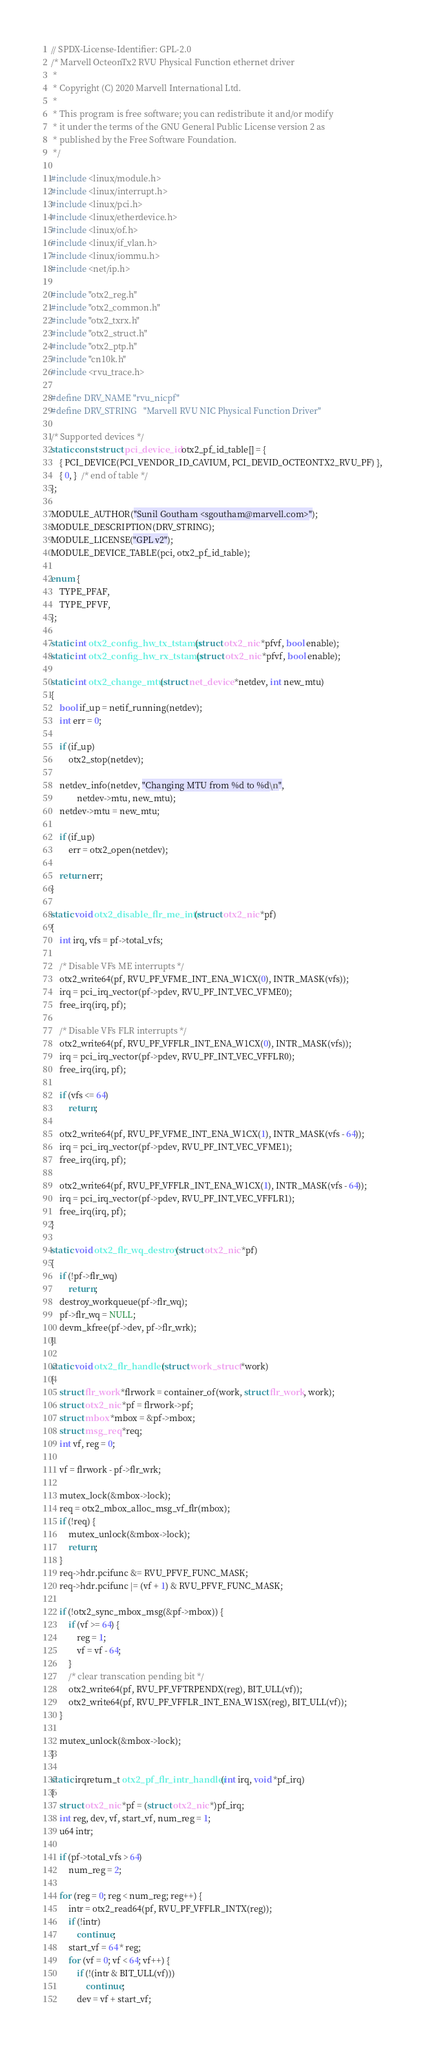Convert code to text. <code><loc_0><loc_0><loc_500><loc_500><_C_>// SPDX-License-Identifier: GPL-2.0
/* Marvell OcteonTx2 RVU Physical Function ethernet driver
 *
 * Copyright (C) 2020 Marvell International Ltd.
 *
 * This program is free software; you can redistribute it and/or modify
 * it under the terms of the GNU General Public License version 2 as
 * published by the Free Software Foundation.
 */

#include <linux/module.h>
#include <linux/interrupt.h>
#include <linux/pci.h>
#include <linux/etherdevice.h>
#include <linux/of.h>
#include <linux/if_vlan.h>
#include <linux/iommu.h>
#include <net/ip.h>

#include "otx2_reg.h"
#include "otx2_common.h"
#include "otx2_txrx.h"
#include "otx2_struct.h"
#include "otx2_ptp.h"
#include "cn10k.h"
#include <rvu_trace.h>

#define DRV_NAME	"rvu_nicpf"
#define DRV_STRING	"Marvell RVU NIC Physical Function Driver"

/* Supported devices */
static const struct pci_device_id otx2_pf_id_table[] = {
	{ PCI_DEVICE(PCI_VENDOR_ID_CAVIUM, PCI_DEVID_OCTEONTX2_RVU_PF) },
	{ 0, }  /* end of table */
};

MODULE_AUTHOR("Sunil Goutham <sgoutham@marvell.com>");
MODULE_DESCRIPTION(DRV_STRING);
MODULE_LICENSE("GPL v2");
MODULE_DEVICE_TABLE(pci, otx2_pf_id_table);

enum {
	TYPE_PFAF,
	TYPE_PFVF,
};

static int otx2_config_hw_tx_tstamp(struct otx2_nic *pfvf, bool enable);
static int otx2_config_hw_rx_tstamp(struct otx2_nic *pfvf, bool enable);

static int otx2_change_mtu(struct net_device *netdev, int new_mtu)
{
	bool if_up = netif_running(netdev);
	int err = 0;

	if (if_up)
		otx2_stop(netdev);

	netdev_info(netdev, "Changing MTU from %d to %d\n",
		    netdev->mtu, new_mtu);
	netdev->mtu = new_mtu;

	if (if_up)
		err = otx2_open(netdev);

	return err;
}

static void otx2_disable_flr_me_intr(struct otx2_nic *pf)
{
	int irq, vfs = pf->total_vfs;

	/* Disable VFs ME interrupts */
	otx2_write64(pf, RVU_PF_VFME_INT_ENA_W1CX(0), INTR_MASK(vfs));
	irq = pci_irq_vector(pf->pdev, RVU_PF_INT_VEC_VFME0);
	free_irq(irq, pf);

	/* Disable VFs FLR interrupts */
	otx2_write64(pf, RVU_PF_VFFLR_INT_ENA_W1CX(0), INTR_MASK(vfs));
	irq = pci_irq_vector(pf->pdev, RVU_PF_INT_VEC_VFFLR0);
	free_irq(irq, pf);

	if (vfs <= 64)
		return;

	otx2_write64(pf, RVU_PF_VFME_INT_ENA_W1CX(1), INTR_MASK(vfs - 64));
	irq = pci_irq_vector(pf->pdev, RVU_PF_INT_VEC_VFME1);
	free_irq(irq, pf);

	otx2_write64(pf, RVU_PF_VFFLR_INT_ENA_W1CX(1), INTR_MASK(vfs - 64));
	irq = pci_irq_vector(pf->pdev, RVU_PF_INT_VEC_VFFLR1);
	free_irq(irq, pf);
}

static void otx2_flr_wq_destroy(struct otx2_nic *pf)
{
	if (!pf->flr_wq)
		return;
	destroy_workqueue(pf->flr_wq);
	pf->flr_wq = NULL;
	devm_kfree(pf->dev, pf->flr_wrk);
}

static void otx2_flr_handler(struct work_struct *work)
{
	struct flr_work *flrwork = container_of(work, struct flr_work, work);
	struct otx2_nic *pf = flrwork->pf;
	struct mbox *mbox = &pf->mbox;
	struct msg_req *req;
	int vf, reg = 0;

	vf = flrwork - pf->flr_wrk;

	mutex_lock(&mbox->lock);
	req = otx2_mbox_alloc_msg_vf_flr(mbox);
	if (!req) {
		mutex_unlock(&mbox->lock);
		return;
	}
	req->hdr.pcifunc &= RVU_PFVF_FUNC_MASK;
	req->hdr.pcifunc |= (vf + 1) & RVU_PFVF_FUNC_MASK;

	if (!otx2_sync_mbox_msg(&pf->mbox)) {
		if (vf >= 64) {
			reg = 1;
			vf = vf - 64;
		}
		/* clear transcation pending bit */
		otx2_write64(pf, RVU_PF_VFTRPENDX(reg), BIT_ULL(vf));
		otx2_write64(pf, RVU_PF_VFFLR_INT_ENA_W1SX(reg), BIT_ULL(vf));
	}

	mutex_unlock(&mbox->lock);
}

static irqreturn_t otx2_pf_flr_intr_handler(int irq, void *pf_irq)
{
	struct otx2_nic *pf = (struct otx2_nic *)pf_irq;
	int reg, dev, vf, start_vf, num_reg = 1;
	u64 intr;

	if (pf->total_vfs > 64)
		num_reg = 2;

	for (reg = 0; reg < num_reg; reg++) {
		intr = otx2_read64(pf, RVU_PF_VFFLR_INTX(reg));
		if (!intr)
			continue;
		start_vf = 64 * reg;
		for (vf = 0; vf < 64; vf++) {
			if (!(intr & BIT_ULL(vf)))
				continue;
			dev = vf + start_vf;</code> 